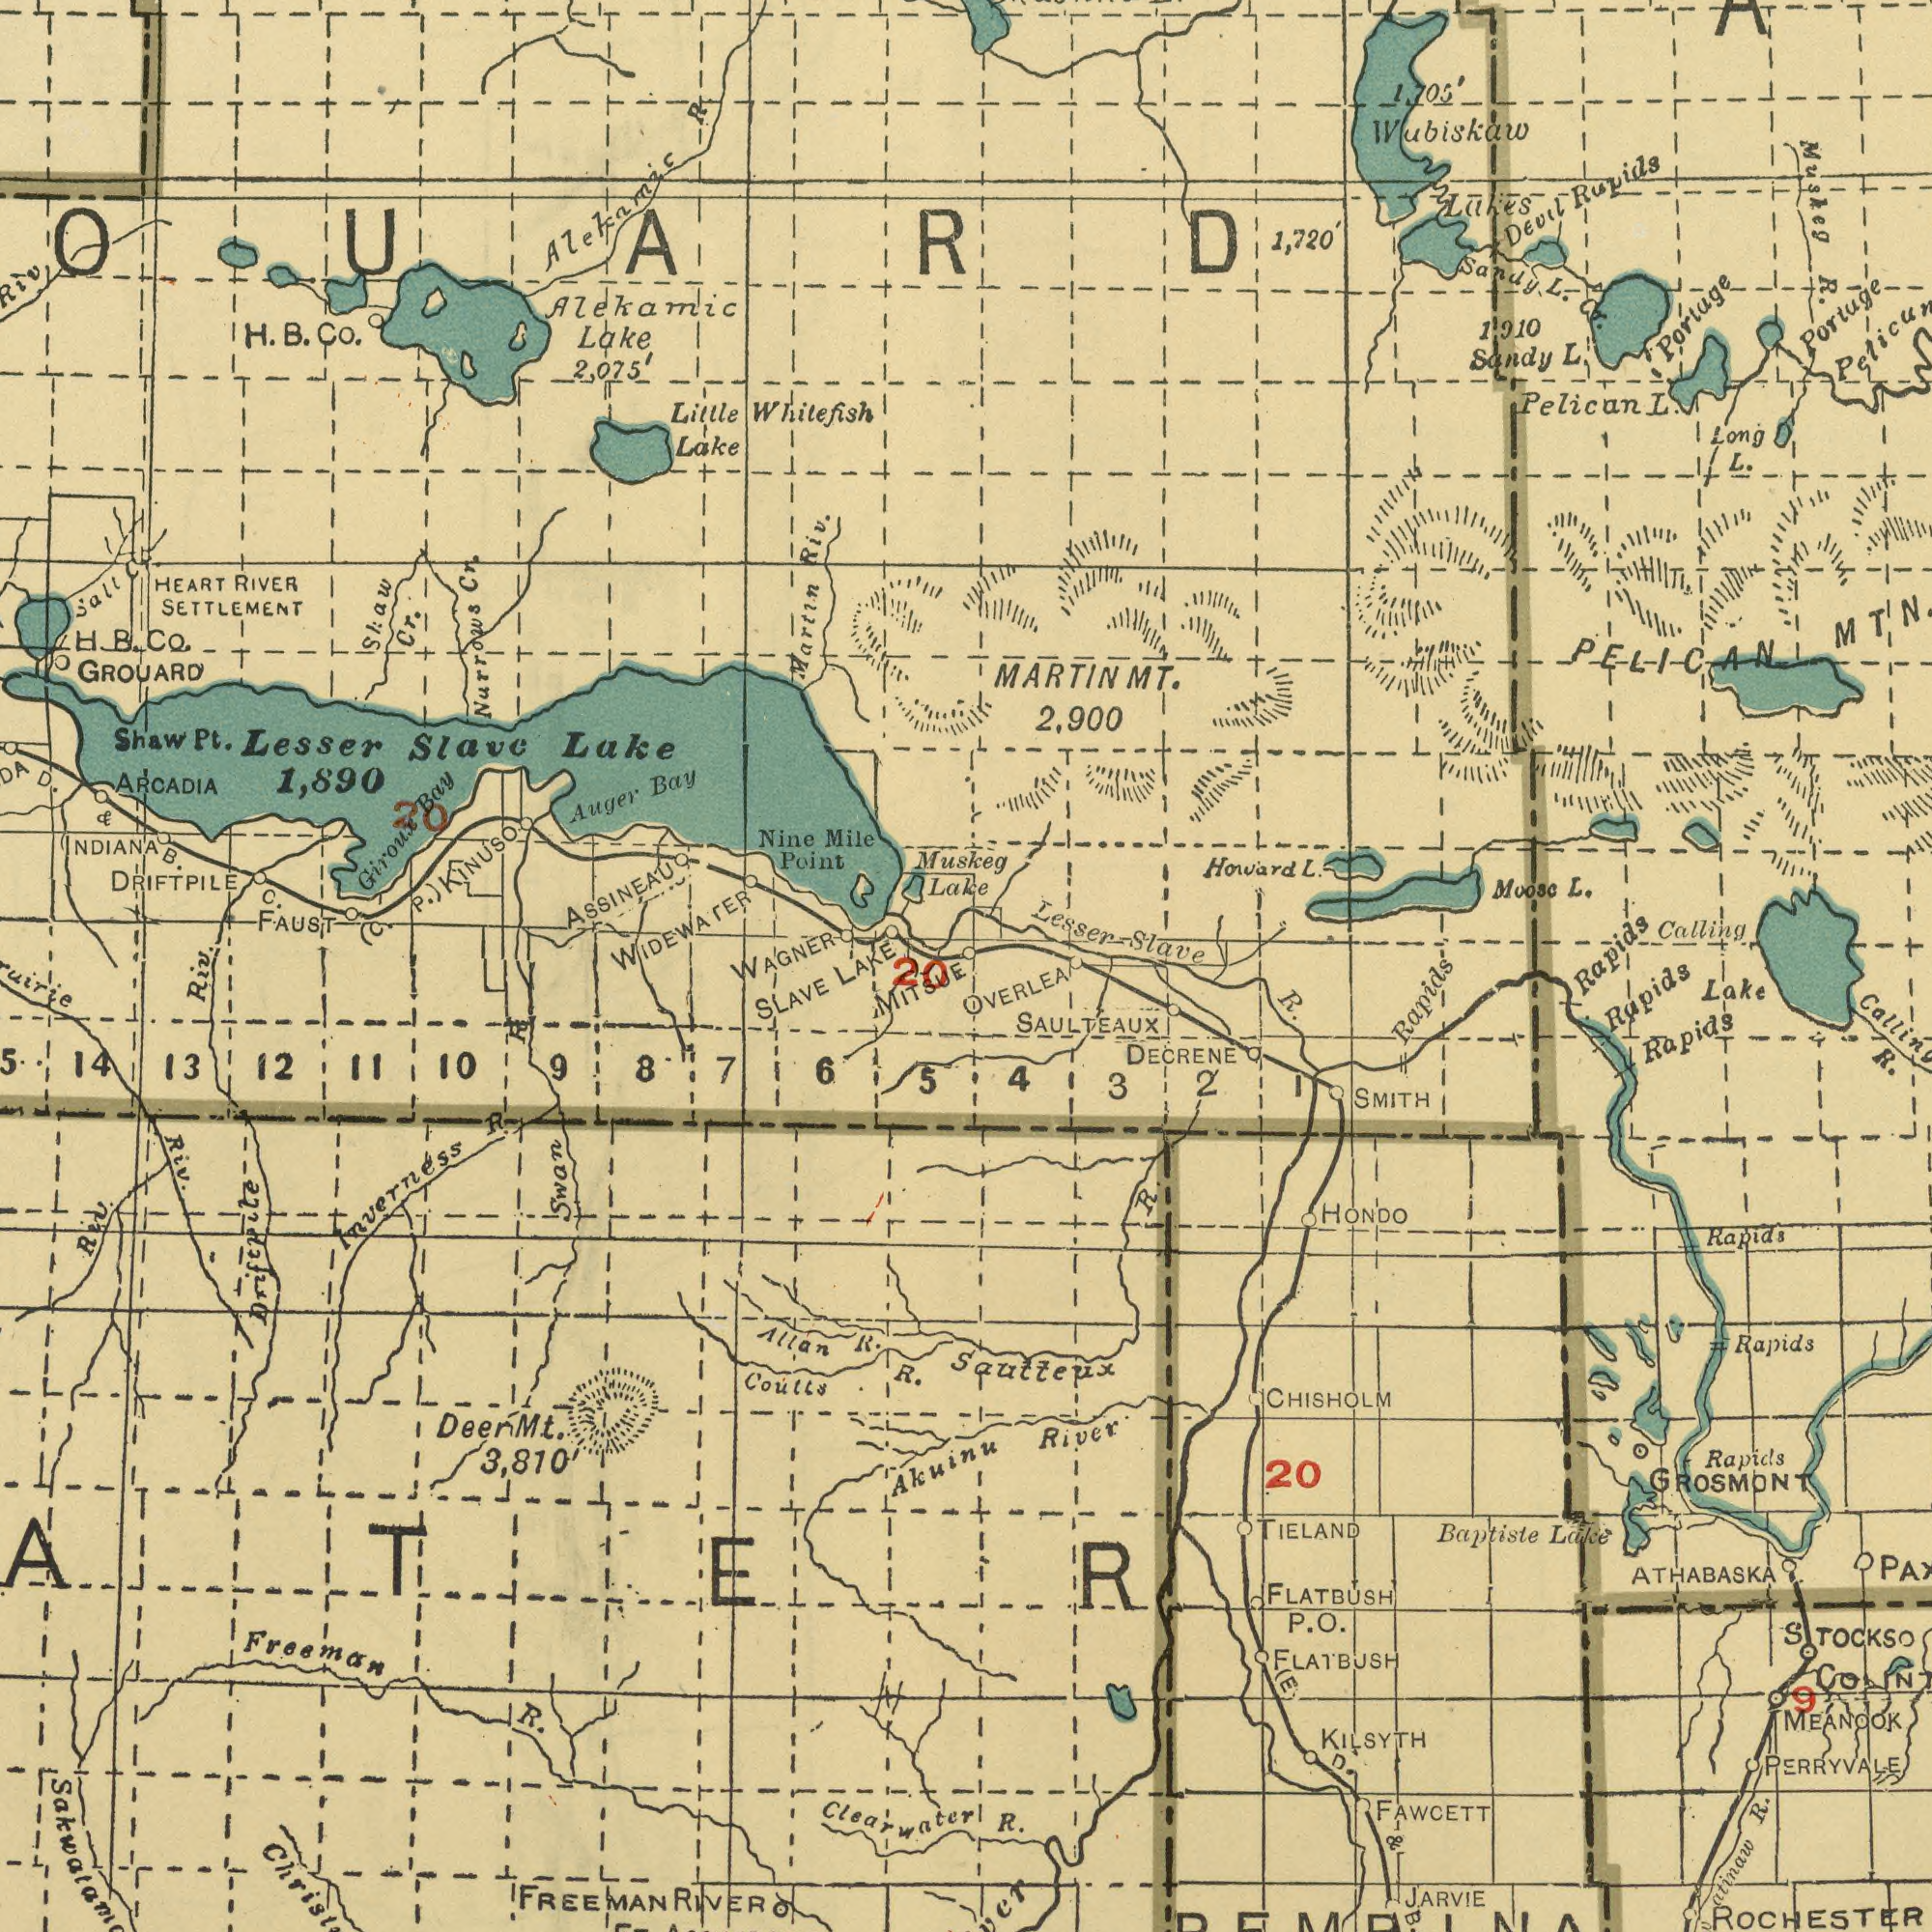What text appears in the bottom-right area of the image? FLATBUSH ATHABASKA FAWCETT R. CHISHOLM SAULTEAUX R. MEANOOK Baptiste Rapids GROSMONT Lake DECRENE Rapids Rapids SMITH Rapids R. JARVIE River OVERLEA ROCHESTER Lake TIELAND PERRYVALE Rapids HONDO 20 STOCKS 4 Sautteux Rapids (E D 2 3 KILSYTH P. R. 1 Co FLATBUSH R. O. & B. 9 What text appears in the top-right area of the image? Wubiskaw Rapids L. Calling Pelican L. R. Moose Portage Howard Sandy Devil Lakes Portage Muskeg PELICAN MTN MARTIN L. L. 1,720' Rapids Sandy L. Lesser Slave 1,910 L. Long 1,705' 2,900 Cr. A MT. What text can you see in the bottom-left section? SLAVE Coutts Riv. Inverness R. Freeman 12 Swan Akuinu 13 R. Riv. Driftpile MITSUE Allan 14 10 R. Riv. R. 15 5 Mt. 3,810' 11 FREEMAN 6 8 Clearwater Deer 9 20 7 R. RIVER What text appears in the top-left area of the image? Slave Whitefish Narrows ASSINEAU GROUARD 1,890 Auger Shaw Lake FAUST INDIANA Little Alekamic Mile Giroux Nine Lake 2,075' ARCADIA Lake RIVER Martin Point Shaw Riv. Salt Bay Lake D. DRIFTPILE Pt. Cr. Bay WIDEWATER HEART C. Muskeg Cr. Lesser B. KINUSO B. R. Co. & (C. H. SETTLEMENT Alekamic H. P.) WAGNER B. Co. LAKE 20 Cr. 